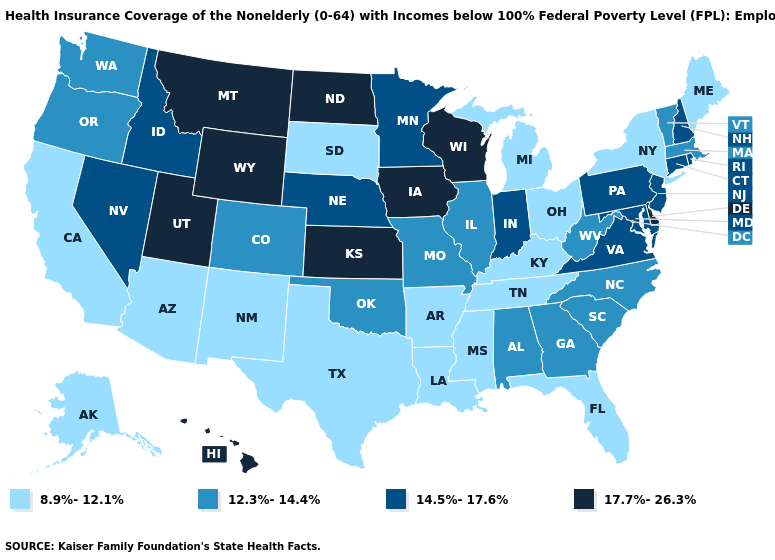What is the lowest value in the USA?
Quick response, please. 8.9%-12.1%. What is the highest value in the South ?
Concise answer only. 17.7%-26.3%. Among the states that border Washington , which have the lowest value?
Be succinct. Oregon. What is the highest value in the South ?
Give a very brief answer. 17.7%-26.3%. Name the states that have a value in the range 12.3%-14.4%?
Answer briefly. Alabama, Colorado, Georgia, Illinois, Massachusetts, Missouri, North Carolina, Oklahoma, Oregon, South Carolina, Vermont, Washington, West Virginia. Does the first symbol in the legend represent the smallest category?
Give a very brief answer. Yes. Name the states that have a value in the range 8.9%-12.1%?
Write a very short answer. Alaska, Arizona, Arkansas, California, Florida, Kentucky, Louisiana, Maine, Michigan, Mississippi, New Mexico, New York, Ohio, South Dakota, Tennessee, Texas. What is the lowest value in the USA?
Concise answer only. 8.9%-12.1%. Does the first symbol in the legend represent the smallest category?
Write a very short answer. Yes. Name the states that have a value in the range 8.9%-12.1%?
Give a very brief answer. Alaska, Arizona, Arkansas, California, Florida, Kentucky, Louisiana, Maine, Michigan, Mississippi, New Mexico, New York, Ohio, South Dakota, Tennessee, Texas. Does Massachusetts have a higher value than Illinois?
Concise answer only. No. Which states hav the highest value in the Northeast?
Concise answer only. Connecticut, New Hampshire, New Jersey, Pennsylvania, Rhode Island. What is the value of Kentucky?
Short answer required. 8.9%-12.1%. Does Maryland have a lower value than Iowa?
Quick response, please. Yes. Which states have the highest value in the USA?
Short answer required. Delaware, Hawaii, Iowa, Kansas, Montana, North Dakota, Utah, Wisconsin, Wyoming. 